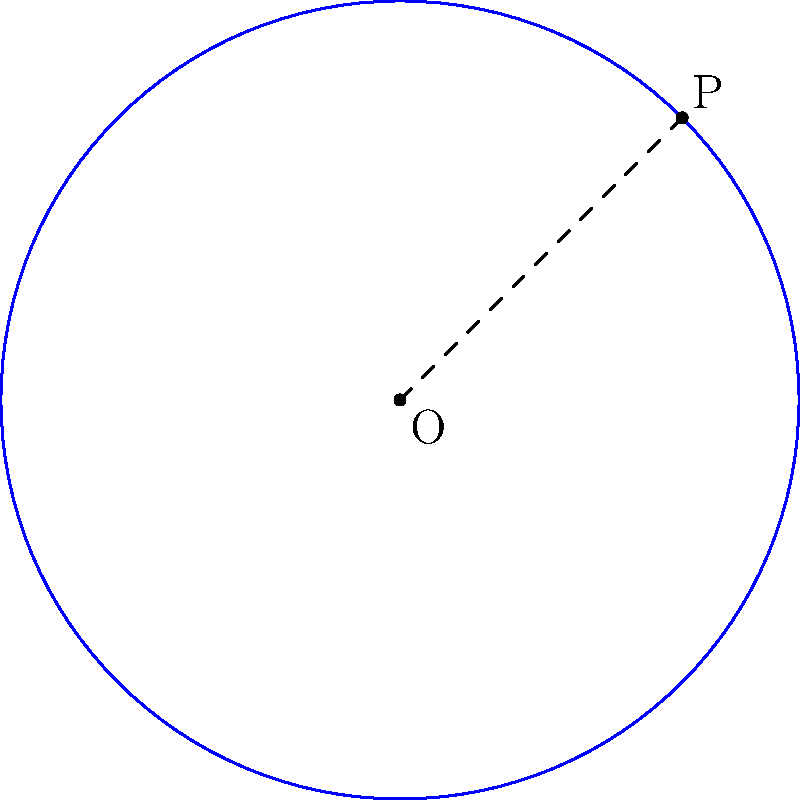Given that the center of a circle is at point O(2,3) and point P(5,6) lies on its circumference, determine the equation of the circle. To find the equation of the circle, we'll follow these steps:

1) The general equation of a circle is $(x-h)^2 + (y-k)^2 = r^2$, where (h,k) is the center and r is the radius.

2) We know the center O(2,3), so h=2 and k=3.

3) To find r, we need to calculate the distance between O and P:
   $r^2 = (x_P-x_O)^2 + (y_P-y_O)^2$
   $r^2 = (5-2)^2 + (6-3)^2$
   $r^2 = 3^2 + 3^2 = 9 + 9 = 18$

4) Now we can write the equation:
   $(x-2)^2 + (y-3)^2 = 18$

5) If we expand this:
   $x^2 - 4x + 4 + y^2 - 6y + 9 = 18$
   $x^2 + y^2 - 4x - 6y - 5 = 0$

This is the equation of the circle in standard form.
Answer: $x^2 + y^2 - 4x - 6y - 5 = 0$ 